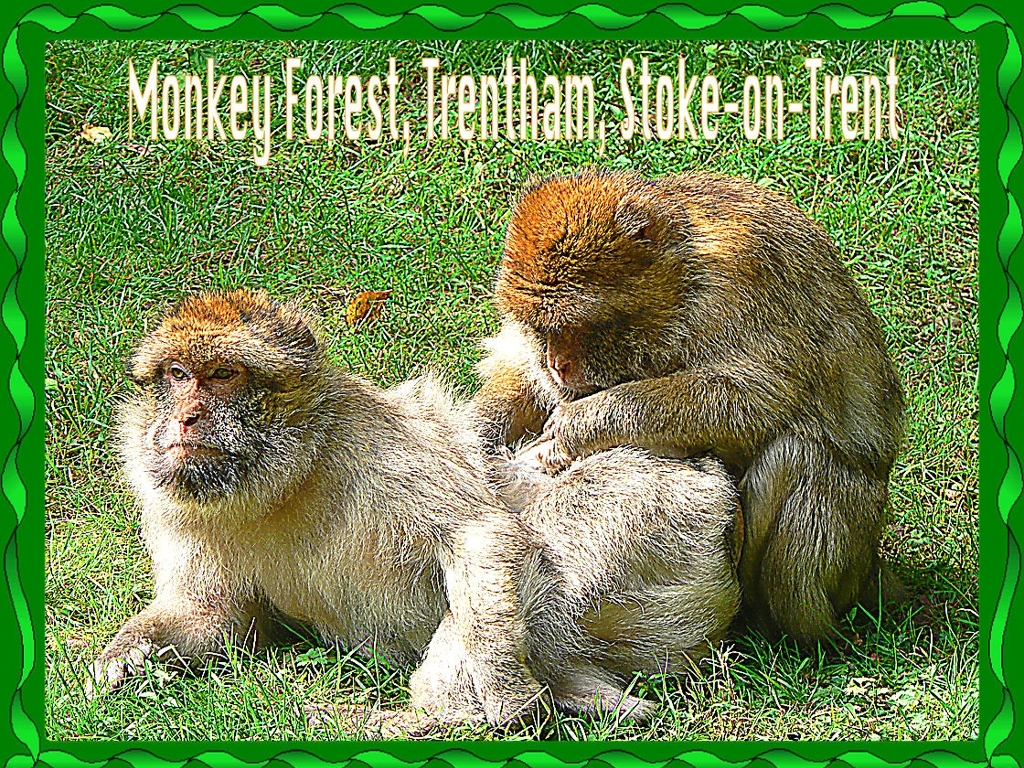Could you describe the surroundings in which these monkeys are found in this image? In this image, the surroundings appear to be a grassy area, which could suggest that the monkeys are in a sanctuary or an open enclosure, possibly within a zoo or a dedicated monkey park. The manicured lawn and absence of trees or forest in the immediate background support this assumption. Are these environments beneficial for the monkeys? Well-designed sanctuaries or enclosures can provide a suitable and safe environment for monkeys, especially in regions where their natural habitat is threatened. These controlled environments can ensure proper nutrition, veterinary care, and opportunities for natural behaviors such as grooming, playing, and establishing social bonds. 